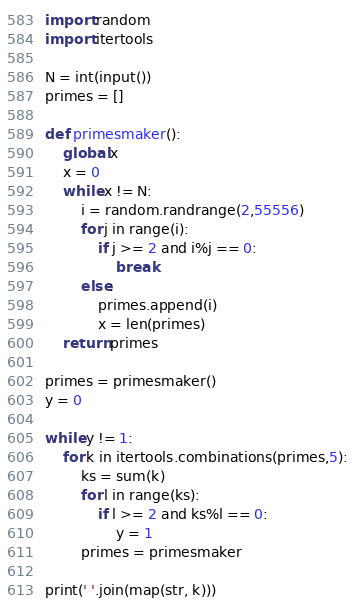Convert code to text. <code><loc_0><loc_0><loc_500><loc_500><_Python_>import random
import itertools

N = int(input())
primes = []

def primesmaker():
    global x
    x = 0
    while x != N:
        i = random.randrange(2,55556)
        for j in range(i):
            if j >= 2 and i%j == 0:
                break
        else:        
            primes.append(i)    
            x = len(primes)
    return primes

primes = primesmaker()
y = 0

while y != 1:
    for k in itertools.combinations(primes,5):
        ks = sum(k)
        for l in range(ks):
            if l >= 2 and ks%l == 0:
                y = 1
        primes = primesmaker

print(' '.join(map(str, k)))
</code> 